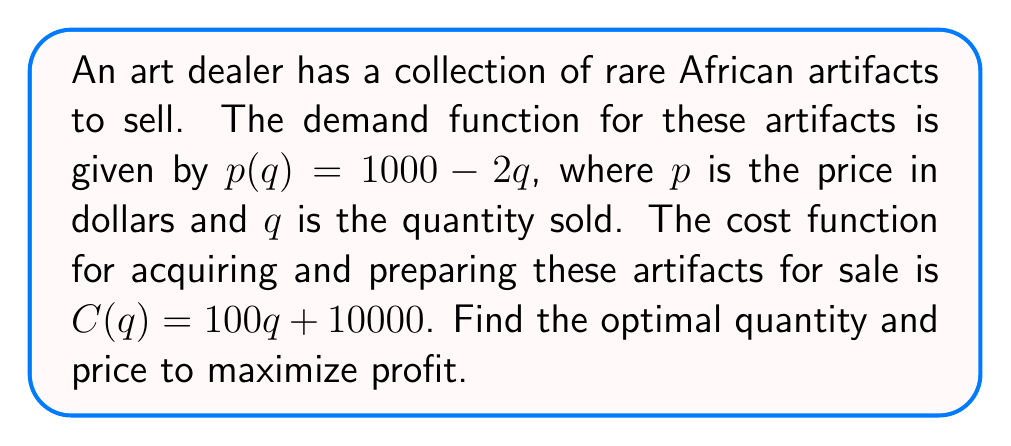Can you solve this math problem? 1) First, we need to find the revenue function $R(q)$:
   $R(q) = p(q) \cdot q = (1000 - 2q) \cdot q = 1000q - 2q^2$

2) The profit function $P(q)$ is revenue minus cost:
   $P(q) = R(q) - C(q) = (1000q - 2q^2) - (100q + 10000) = 900q - 2q^2 - 10000$

3) To maximize profit, we find where the derivative of $P(q)$ equals zero:
   $$\frac{dP}{dq} = 900 - 4q$$
   
   Set this equal to zero:
   $900 - 4q = 0$
   $4q = 900$
   $q = 225$

4) Verify this is a maximum by checking the second derivative:
   $$\frac{d^2P}{dq^2} = -4$$
   Since this is negative, $q = 225$ gives a maximum.

5) To find the optimal price, we substitute $q = 225$ into the demand function:
   $p(225) = 1000 - 2(225) = 550$

Therefore, the optimal quantity is 225 artifacts, and the optimal price is $550 per artifact.
Answer: Quantity: 225, Price: $550 